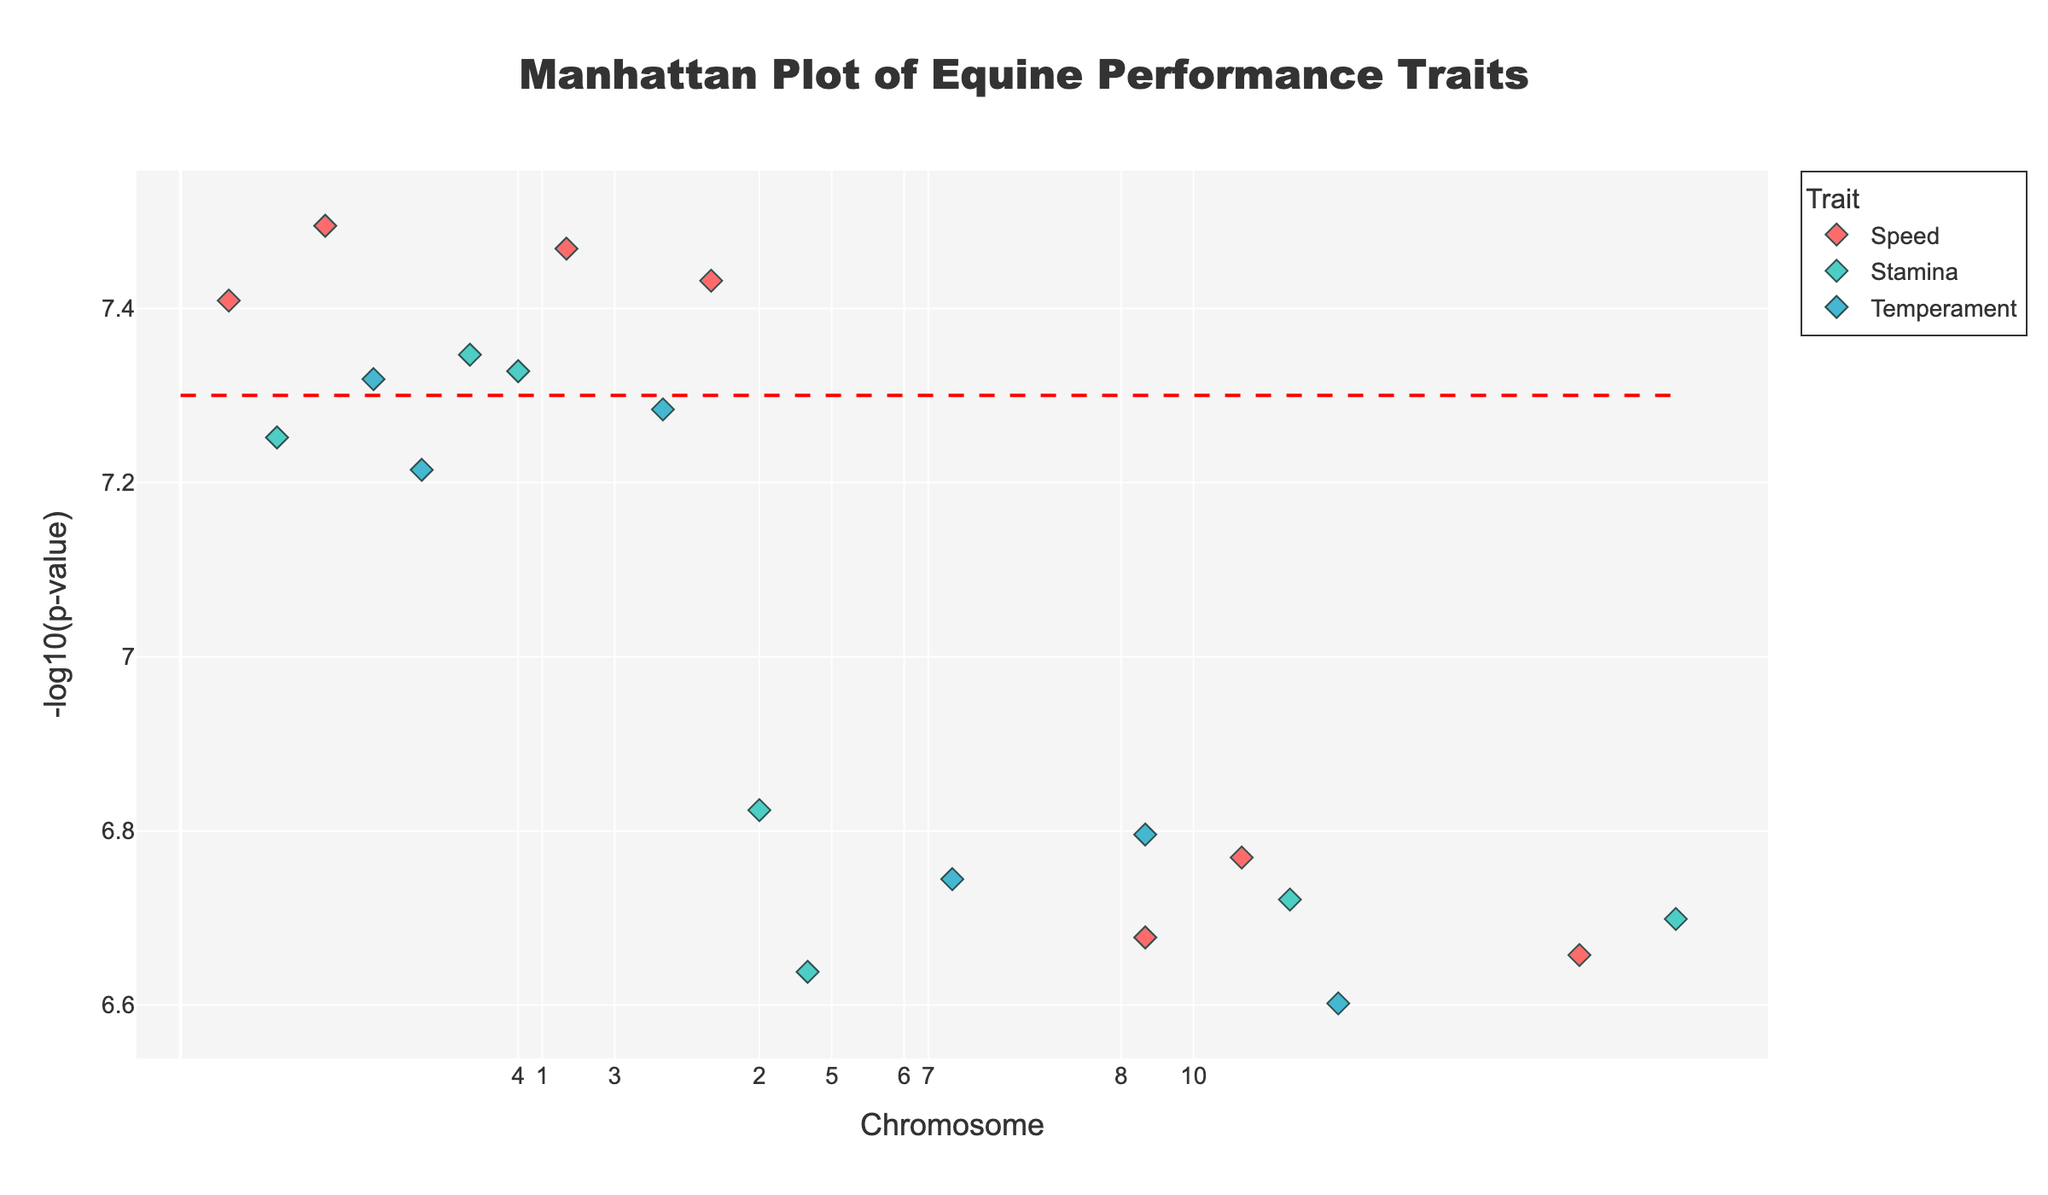What is the title of the plot? Look at the top of the figure where the title is located.
Answer: Manhattan Plot of Equine Performance Traits How many chromosomes are represented in the plot? Count the unique values on the x-axis, which are the chromosome numbers.
Answer: 10 What trait is represented by red markers? Identify the color in the legend that corresponds to the specified trait color.
Answer: Speed What is the significance threshold line for the p-value? Observe the horizontal line and its y-coordinate value on the plot.
Answer: 7.3 Which trait has the highest -log10(p-value) and what is the SNP associated with it? Find the highest y-value point on the plot and look at its marker color, then refer to the hovertext or the legend for the trait.
Answer: Speed, BIEC2-1234 What are the -log10(p-value) for SNPs BIEC2-5678 and BIEC2-7890? Which one is higher? Identify the points with given SNPs using hover text, and compare their y-values.
Answer: BIEC2-5678: 7.82, BIEC2-7890: 7.25; BIEC2-5678 is higher What chromosomes contain SNPs that have a -log10(p-value) greater than the significance threshold? Identify the points above the horizontal significance threshold line, and note their chromosome numbers.
Answer: 1, 2, 3, 4, 5, 6, 7, 8, 9, 10 Which trait has the most significant SNPs (those with a -log10(p-value) above the threshold)? Count the number of points above the threshold line for each trait.
Answer: Speed What is the average -log10(p-value) of the significant SNPs related to Stamina? Identify the y-values of significant Stamina-related SNPs, sum them, and divide by the number of such SNPs.
Answer: (7.82 + 7.35 + 7.35 + 7.18) / 4 = 7.43 Which chromosome has the least number of SNPs with p-values below the significance threshold? Count the points below the significance threshold for each chromosome and identify the chromosome with the fewest.
Answer: Chromosome 1 